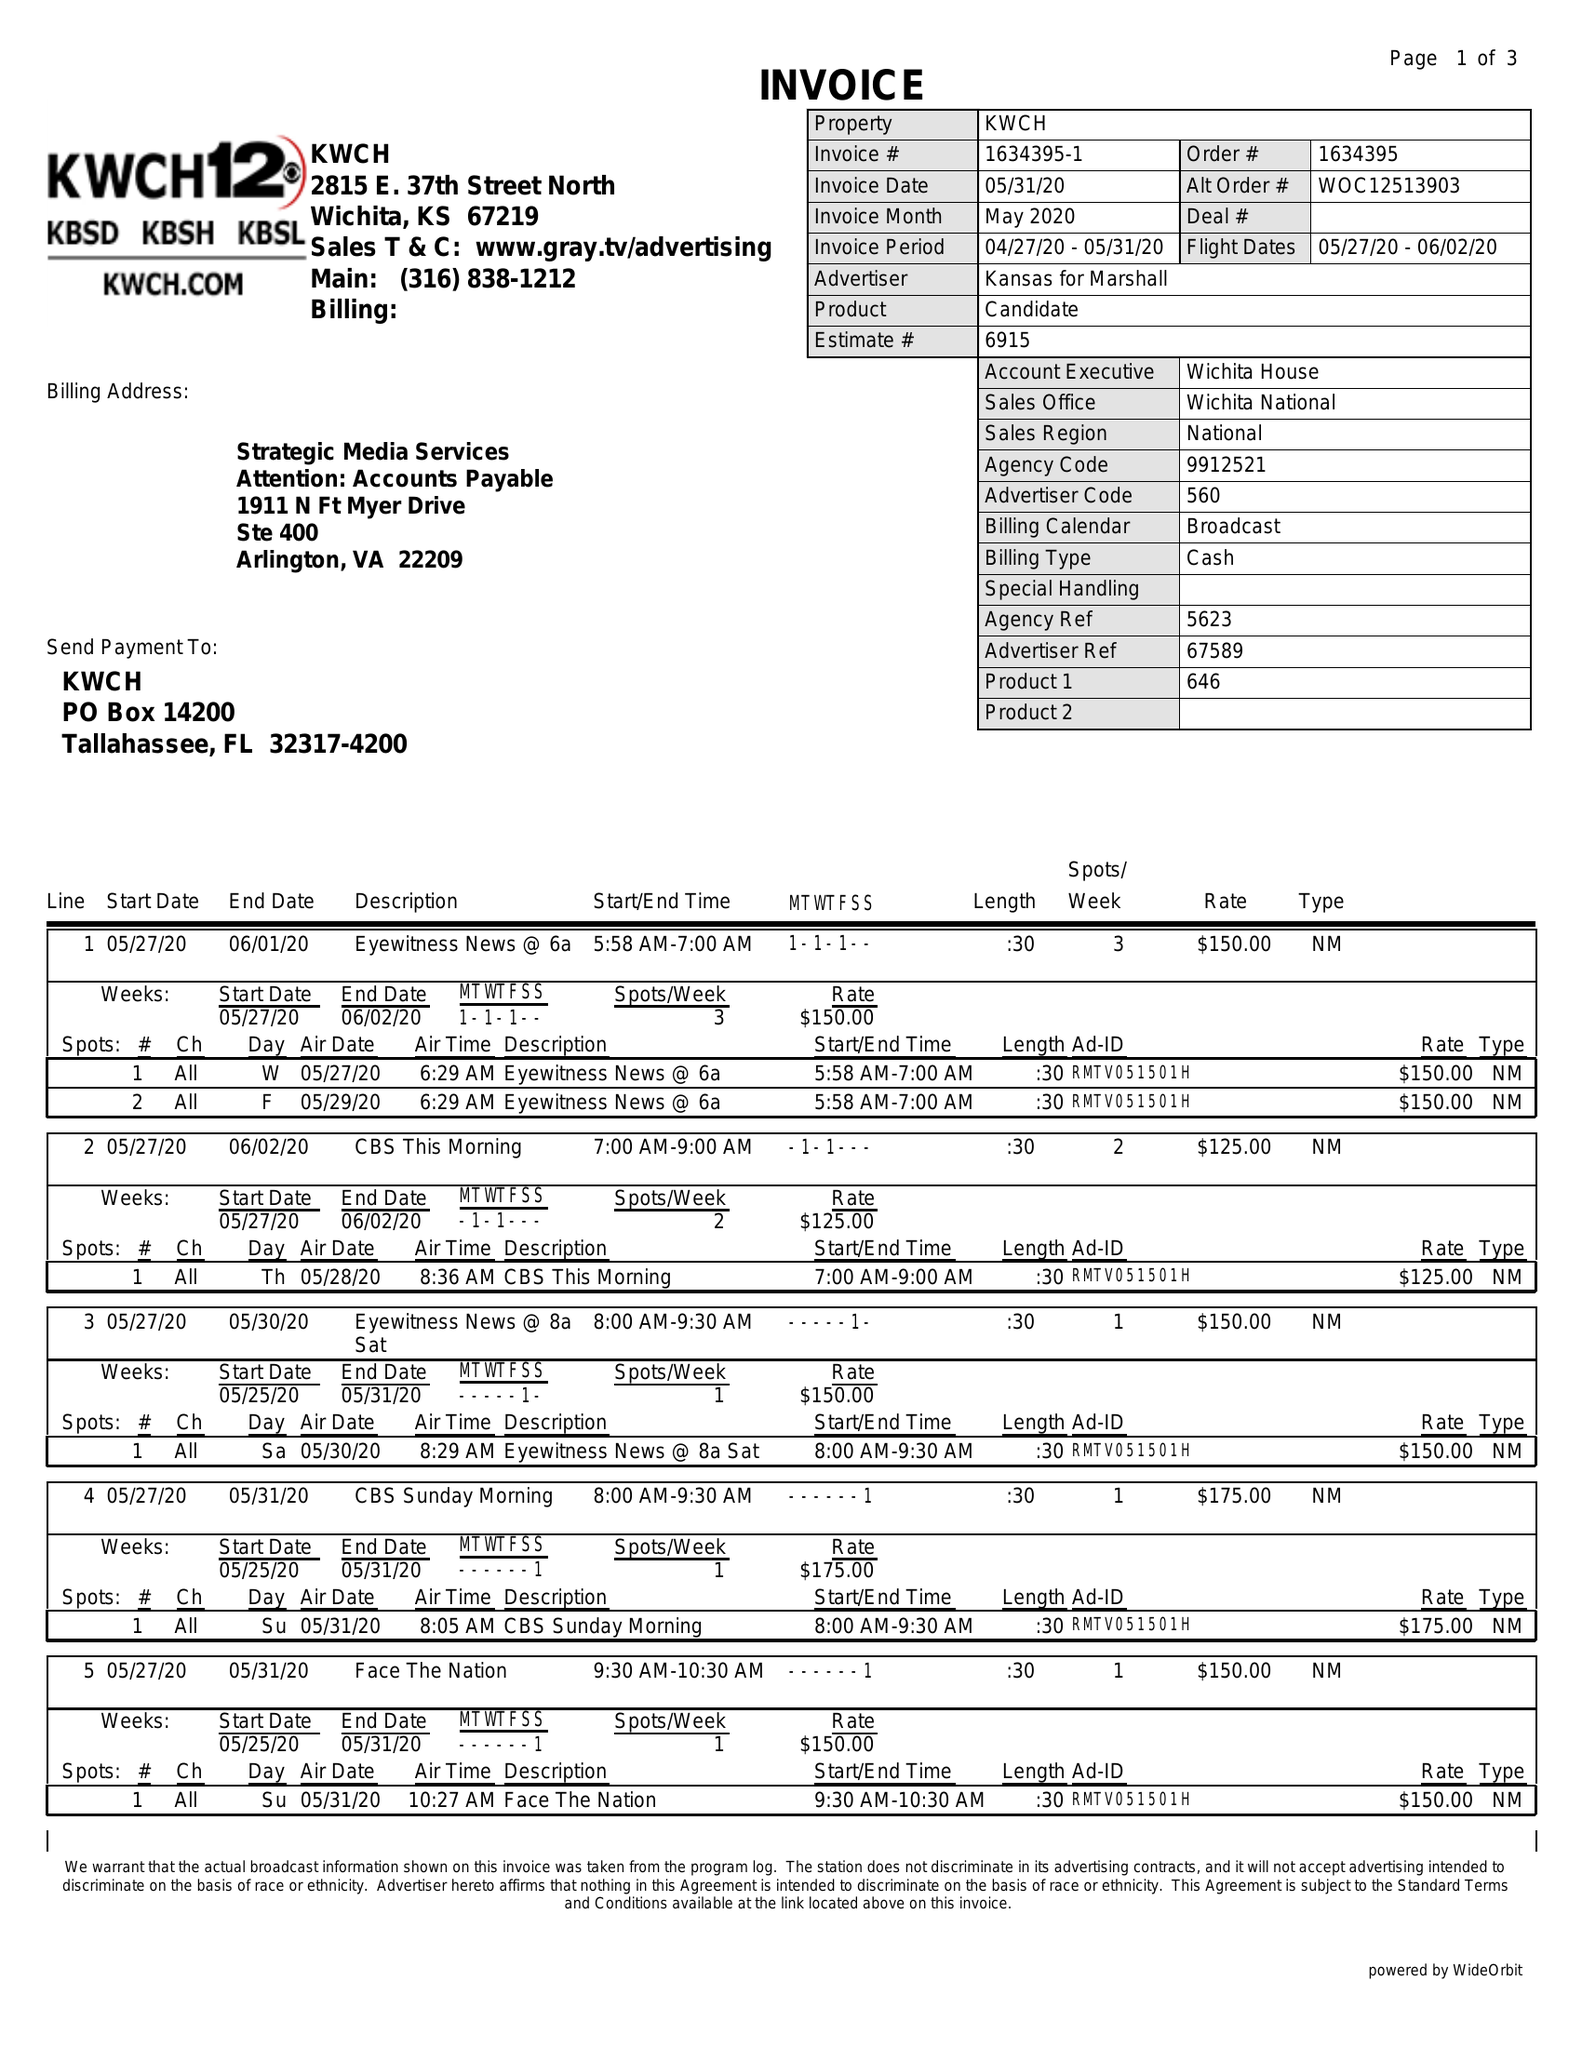What is the value for the contract_num?
Answer the question using a single word or phrase. 1634395 